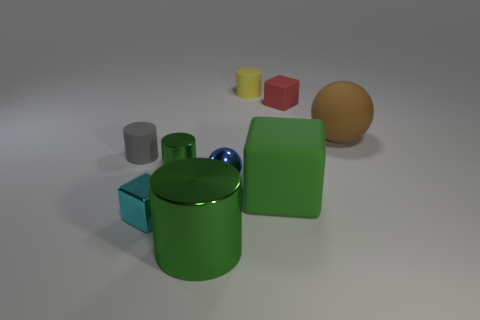Add 1 gray rubber cylinders. How many objects exist? 10 Subtract all blocks. How many objects are left? 6 Add 3 tiny green metallic blocks. How many tiny green metallic blocks exist? 3 Subtract 2 green cylinders. How many objects are left? 7 Subtract all shiny cylinders. Subtract all big rubber objects. How many objects are left? 5 Add 5 small green things. How many small green things are left? 6 